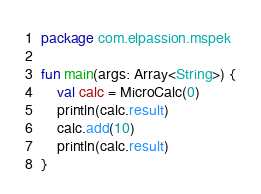Convert code to text. <code><loc_0><loc_0><loc_500><loc_500><_Kotlin_>package com.elpassion.mspek

fun main(args: Array<String>) {
    val calc = MicroCalc(0)
    println(calc.result)
    calc.add(10)
    println(calc.result)
}

</code> 